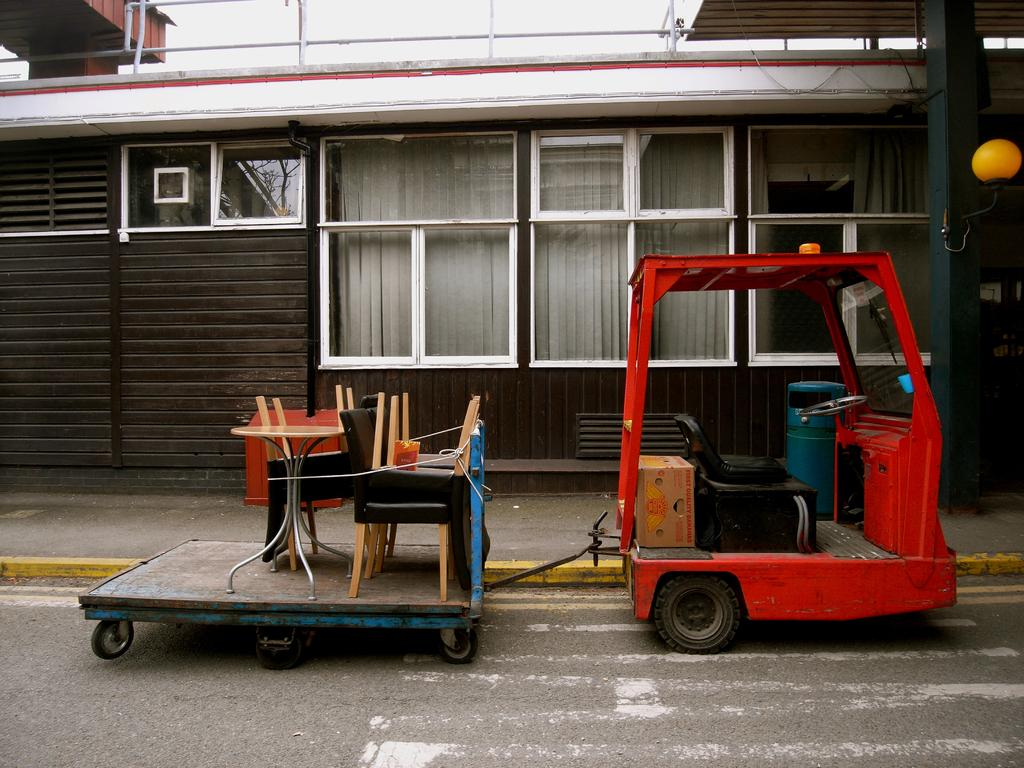What is the main subject of the image? The main subject of the image is a vehicle connected to a trolley. What is on the trolley? There are objects on the trolley. What can be seen in the background of the image? There is a building in the background of the image. How many eyes can be seen on the vehicle in the image? There are no eyes visible on the vehicle in the image, as vehicles do not have eyes. 